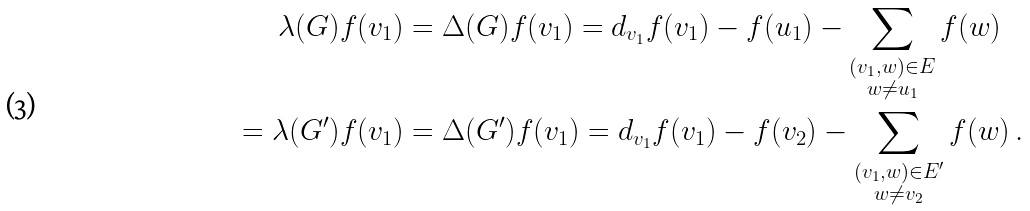Convert formula to latex. <formula><loc_0><loc_0><loc_500><loc_500>\lambda ( G ) f ( v _ { 1 } ) & = \Delta ( G ) f ( v _ { 1 } ) = d _ { v _ { 1 } } f ( v _ { 1 } ) - f ( u _ { 1 } ) - \sum _ { \substack { ( v _ { 1 } , w ) \in E \\ w \not = u _ { 1 } } } f ( w ) \\ = \lambda ( G ^ { \prime } ) f ( v _ { 1 } ) & = \Delta ( G ^ { \prime } ) f ( v _ { 1 } ) = d _ { v _ { 1 } } f ( v _ { 1 } ) - f ( v _ { 2 } ) - \sum _ { \substack { ( v _ { 1 } , w ) \in E ^ { \prime } \\ w \not = v _ { 2 } } } f ( w ) \, . \\</formula> 